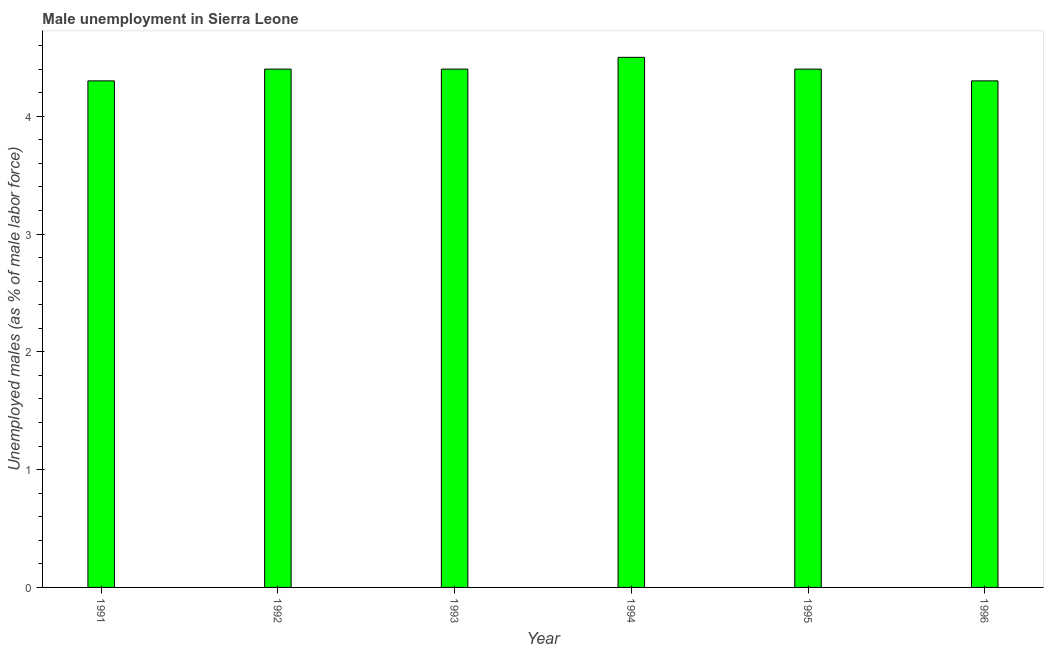What is the title of the graph?
Offer a terse response. Male unemployment in Sierra Leone. What is the label or title of the Y-axis?
Provide a succinct answer. Unemployed males (as % of male labor force). What is the unemployed males population in 1993?
Offer a very short reply. 4.4. Across all years, what is the minimum unemployed males population?
Give a very brief answer. 4.3. In which year was the unemployed males population maximum?
Ensure brevity in your answer.  1994. In which year was the unemployed males population minimum?
Provide a short and direct response. 1991. What is the sum of the unemployed males population?
Provide a short and direct response. 26.3. What is the average unemployed males population per year?
Your response must be concise. 4.38. What is the median unemployed males population?
Give a very brief answer. 4.4. In how many years, is the unemployed males population greater than 0.4 %?
Your answer should be compact. 6. Do a majority of the years between 1992 and 1995 (inclusive) have unemployed males population greater than 0.8 %?
Make the answer very short. Yes. What is the ratio of the unemployed males population in 1992 to that in 1996?
Your response must be concise. 1.02. Is the unemployed males population in 1992 less than that in 1993?
Ensure brevity in your answer.  No. Is the sum of the unemployed males population in 1991 and 1994 greater than the maximum unemployed males population across all years?
Make the answer very short. Yes. What is the difference between the highest and the lowest unemployed males population?
Ensure brevity in your answer.  0.2. In how many years, is the unemployed males population greater than the average unemployed males population taken over all years?
Keep it short and to the point. 4. How many bars are there?
Ensure brevity in your answer.  6. Are the values on the major ticks of Y-axis written in scientific E-notation?
Provide a succinct answer. No. What is the Unemployed males (as % of male labor force) in 1991?
Provide a succinct answer. 4.3. What is the Unemployed males (as % of male labor force) in 1992?
Keep it short and to the point. 4.4. What is the Unemployed males (as % of male labor force) of 1993?
Your response must be concise. 4.4. What is the Unemployed males (as % of male labor force) in 1994?
Offer a very short reply. 4.5. What is the Unemployed males (as % of male labor force) in 1995?
Offer a very short reply. 4.4. What is the Unemployed males (as % of male labor force) of 1996?
Offer a very short reply. 4.3. What is the difference between the Unemployed males (as % of male labor force) in 1991 and 1994?
Your answer should be compact. -0.2. What is the difference between the Unemployed males (as % of male labor force) in 1991 and 1995?
Your response must be concise. -0.1. What is the difference between the Unemployed males (as % of male labor force) in 1991 and 1996?
Your answer should be very brief. 0. What is the difference between the Unemployed males (as % of male labor force) in 1992 and 1993?
Provide a succinct answer. 0. What is the difference between the Unemployed males (as % of male labor force) in 1992 and 1994?
Offer a terse response. -0.1. What is the difference between the Unemployed males (as % of male labor force) in 1992 and 1995?
Provide a short and direct response. 0. What is the difference between the Unemployed males (as % of male labor force) in 1992 and 1996?
Give a very brief answer. 0.1. What is the difference between the Unemployed males (as % of male labor force) in 1995 and 1996?
Offer a terse response. 0.1. What is the ratio of the Unemployed males (as % of male labor force) in 1991 to that in 1992?
Keep it short and to the point. 0.98. What is the ratio of the Unemployed males (as % of male labor force) in 1991 to that in 1994?
Your answer should be very brief. 0.96. What is the ratio of the Unemployed males (as % of male labor force) in 1992 to that in 1995?
Your answer should be compact. 1. What is the ratio of the Unemployed males (as % of male labor force) in 1992 to that in 1996?
Your answer should be very brief. 1.02. What is the ratio of the Unemployed males (as % of male labor force) in 1994 to that in 1996?
Give a very brief answer. 1.05. 